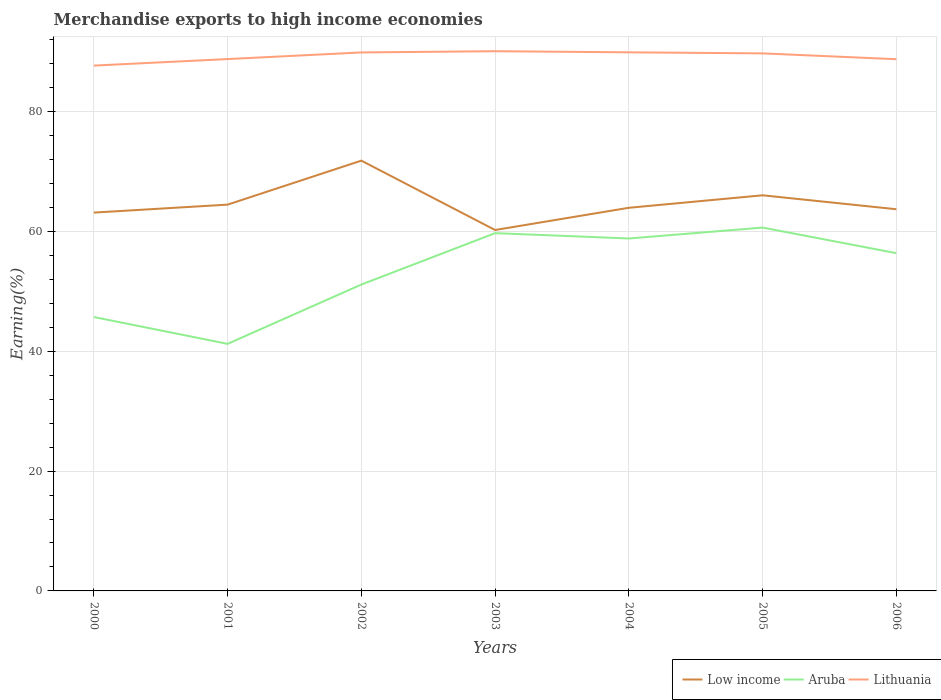How many different coloured lines are there?
Provide a succinct answer. 3. Does the line corresponding to Lithuania intersect with the line corresponding to Aruba?
Provide a succinct answer. No. Across all years, what is the maximum percentage of amount earned from merchandise exports in Low income?
Offer a terse response. 60.23. In which year was the percentage of amount earned from merchandise exports in Low income maximum?
Offer a terse response. 2003. What is the total percentage of amount earned from merchandise exports in Low income in the graph?
Offer a terse response. 5.78. What is the difference between the highest and the second highest percentage of amount earned from merchandise exports in Lithuania?
Give a very brief answer. 2.4. What is the difference between the highest and the lowest percentage of amount earned from merchandise exports in Lithuania?
Make the answer very short. 4. Are the values on the major ticks of Y-axis written in scientific E-notation?
Keep it short and to the point. No. Does the graph contain grids?
Ensure brevity in your answer.  Yes. Where does the legend appear in the graph?
Make the answer very short. Bottom right. What is the title of the graph?
Your answer should be compact. Merchandise exports to high income economies. Does "Iran" appear as one of the legend labels in the graph?
Offer a terse response. No. What is the label or title of the Y-axis?
Give a very brief answer. Earning(%). What is the Earning(%) of Low income in 2000?
Provide a succinct answer. 63.13. What is the Earning(%) in Aruba in 2000?
Ensure brevity in your answer.  45.71. What is the Earning(%) of Lithuania in 2000?
Your response must be concise. 87.66. What is the Earning(%) in Low income in 2001?
Provide a succinct answer. 64.46. What is the Earning(%) of Aruba in 2001?
Keep it short and to the point. 41.23. What is the Earning(%) in Lithuania in 2001?
Your response must be concise. 88.75. What is the Earning(%) of Low income in 2002?
Your answer should be compact. 71.8. What is the Earning(%) of Aruba in 2002?
Provide a succinct answer. 51.13. What is the Earning(%) of Lithuania in 2002?
Give a very brief answer. 89.86. What is the Earning(%) in Low income in 2003?
Offer a very short reply. 60.23. What is the Earning(%) of Aruba in 2003?
Offer a terse response. 59.7. What is the Earning(%) of Lithuania in 2003?
Your answer should be very brief. 90.06. What is the Earning(%) in Low income in 2004?
Ensure brevity in your answer.  63.93. What is the Earning(%) in Aruba in 2004?
Make the answer very short. 58.81. What is the Earning(%) of Lithuania in 2004?
Keep it short and to the point. 89.87. What is the Earning(%) in Low income in 2005?
Your answer should be very brief. 66.02. What is the Earning(%) in Aruba in 2005?
Ensure brevity in your answer.  60.63. What is the Earning(%) in Lithuania in 2005?
Your response must be concise. 89.7. What is the Earning(%) in Low income in 2006?
Keep it short and to the point. 63.69. What is the Earning(%) in Aruba in 2006?
Your answer should be very brief. 56.36. What is the Earning(%) of Lithuania in 2006?
Ensure brevity in your answer.  88.73. Across all years, what is the maximum Earning(%) in Low income?
Make the answer very short. 71.8. Across all years, what is the maximum Earning(%) in Aruba?
Provide a short and direct response. 60.63. Across all years, what is the maximum Earning(%) in Lithuania?
Offer a terse response. 90.06. Across all years, what is the minimum Earning(%) of Low income?
Your answer should be compact. 60.23. Across all years, what is the minimum Earning(%) of Aruba?
Provide a succinct answer. 41.23. Across all years, what is the minimum Earning(%) of Lithuania?
Your answer should be compact. 87.66. What is the total Earning(%) of Low income in the graph?
Offer a very short reply. 453.26. What is the total Earning(%) in Aruba in the graph?
Offer a very short reply. 373.56. What is the total Earning(%) of Lithuania in the graph?
Ensure brevity in your answer.  624.63. What is the difference between the Earning(%) of Low income in 2000 and that in 2001?
Your answer should be compact. -1.33. What is the difference between the Earning(%) of Aruba in 2000 and that in 2001?
Offer a terse response. 4.48. What is the difference between the Earning(%) in Lithuania in 2000 and that in 2001?
Your response must be concise. -1.09. What is the difference between the Earning(%) of Low income in 2000 and that in 2002?
Provide a succinct answer. -8.67. What is the difference between the Earning(%) of Aruba in 2000 and that in 2002?
Provide a succinct answer. -5.42. What is the difference between the Earning(%) in Lithuania in 2000 and that in 2002?
Provide a succinct answer. -2.2. What is the difference between the Earning(%) of Low income in 2000 and that in 2003?
Ensure brevity in your answer.  2.9. What is the difference between the Earning(%) of Aruba in 2000 and that in 2003?
Your response must be concise. -14. What is the difference between the Earning(%) of Lithuania in 2000 and that in 2003?
Provide a succinct answer. -2.4. What is the difference between the Earning(%) of Low income in 2000 and that in 2004?
Make the answer very short. -0.8. What is the difference between the Earning(%) in Aruba in 2000 and that in 2004?
Provide a short and direct response. -13.11. What is the difference between the Earning(%) of Lithuania in 2000 and that in 2004?
Provide a short and direct response. -2.21. What is the difference between the Earning(%) in Low income in 2000 and that in 2005?
Ensure brevity in your answer.  -2.89. What is the difference between the Earning(%) in Aruba in 2000 and that in 2005?
Offer a very short reply. -14.93. What is the difference between the Earning(%) of Lithuania in 2000 and that in 2005?
Your response must be concise. -2.04. What is the difference between the Earning(%) of Low income in 2000 and that in 2006?
Offer a very short reply. -0.56. What is the difference between the Earning(%) in Aruba in 2000 and that in 2006?
Provide a short and direct response. -10.66. What is the difference between the Earning(%) in Lithuania in 2000 and that in 2006?
Make the answer very short. -1.07. What is the difference between the Earning(%) in Low income in 2001 and that in 2002?
Offer a terse response. -7.34. What is the difference between the Earning(%) in Aruba in 2001 and that in 2002?
Keep it short and to the point. -9.9. What is the difference between the Earning(%) in Lithuania in 2001 and that in 2002?
Offer a very short reply. -1.11. What is the difference between the Earning(%) of Low income in 2001 and that in 2003?
Offer a terse response. 4.23. What is the difference between the Earning(%) of Aruba in 2001 and that in 2003?
Your response must be concise. -18.48. What is the difference between the Earning(%) of Lithuania in 2001 and that in 2003?
Your response must be concise. -1.31. What is the difference between the Earning(%) of Low income in 2001 and that in 2004?
Your answer should be very brief. 0.53. What is the difference between the Earning(%) in Aruba in 2001 and that in 2004?
Keep it short and to the point. -17.59. What is the difference between the Earning(%) in Lithuania in 2001 and that in 2004?
Keep it short and to the point. -1.13. What is the difference between the Earning(%) in Low income in 2001 and that in 2005?
Give a very brief answer. -1.56. What is the difference between the Earning(%) in Aruba in 2001 and that in 2005?
Provide a short and direct response. -19.41. What is the difference between the Earning(%) of Lithuania in 2001 and that in 2005?
Offer a very short reply. -0.95. What is the difference between the Earning(%) in Low income in 2001 and that in 2006?
Keep it short and to the point. 0.77. What is the difference between the Earning(%) of Aruba in 2001 and that in 2006?
Your response must be concise. -15.14. What is the difference between the Earning(%) of Lithuania in 2001 and that in 2006?
Offer a terse response. 0.02. What is the difference between the Earning(%) of Low income in 2002 and that in 2003?
Make the answer very short. 11.57. What is the difference between the Earning(%) of Aruba in 2002 and that in 2003?
Keep it short and to the point. -8.58. What is the difference between the Earning(%) in Lithuania in 2002 and that in 2003?
Offer a terse response. -0.2. What is the difference between the Earning(%) of Low income in 2002 and that in 2004?
Make the answer very short. 7.87. What is the difference between the Earning(%) in Aruba in 2002 and that in 2004?
Offer a very short reply. -7.69. What is the difference between the Earning(%) of Lithuania in 2002 and that in 2004?
Give a very brief answer. -0.02. What is the difference between the Earning(%) of Low income in 2002 and that in 2005?
Provide a short and direct response. 5.78. What is the difference between the Earning(%) of Aruba in 2002 and that in 2005?
Give a very brief answer. -9.51. What is the difference between the Earning(%) in Lithuania in 2002 and that in 2005?
Your response must be concise. 0.16. What is the difference between the Earning(%) of Low income in 2002 and that in 2006?
Provide a succinct answer. 8.11. What is the difference between the Earning(%) in Aruba in 2002 and that in 2006?
Provide a short and direct response. -5.24. What is the difference between the Earning(%) of Lithuania in 2002 and that in 2006?
Provide a short and direct response. 1.13. What is the difference between the Earning(%) of Low income in 2003 and that in 2004?
Offer a very short reply. -3.71. What is the difference between the Earning(%) in Aruba in 2003 and that in 2004?
Provide a short and direct response. 0.89. What is the difference between the Earning(%) of Lithuania in 2003 and that in 2004?
Your response must be concise. 0.19. What is the difference between the Earning(%) in Low income in 2003 and that in 2005?
Keep it short and to the point. -5.79. What is the difference between the Earning(%) in Aruba in 2003 and that in 2005?
Offer a very short reply. -0.93. What is the difference between the Earning(%) of Lithuania in 2003 and that in 2005?
Your answer should be very brief. 0.36. What is the difference between the Earning(%) in Low income in 2003 and that in 2006?
Provide a succinct answer. -3.47. What is the difference between the Earning(%) in Aruba in 2003 and that in 2006?
Your answer should be very brief. 3.34. What is the difference between the Earning(%) in Lithuania in 2003 and that in 2006?
Offer a terse response. 1.33. What is the difference between the Earning(%) of Low income in 2004 and that in 2005?
Provide a succinct answer. -2.08. What is the difference between the Earning(%) of Aruba in 2004 and that in 2005?
Ensure brevity in your answer.  -1.82. What is the difference between the Earning(%) of Lithuania in 2004 and that in 2005?
Your answer should be very brief. 0.18. What is the difference between the Earning(%) in Low income in 2004 and that in 2006?
Provide a succinct answer. 0.24. What is the difference between the Earning(%) of Aruba in 2004 and that in 2006?
Your response must be concise. 2.45. What is the difference between the Earning(%) of Lithuania in 2004 and that in 2006?
Your response must be concise. 1.15. What is the difference between the Earning(%) in Low income in 2005 and that in 2006?
Ensure brevity in your answer.  2.33. What is the difference between the Earning(%) of Aruba in 2005 and that in 2006?
Ensure brevity in your answer.  4.27. What is the difference between the Earning(%) of Lithuania in 2005 and that in 2006?
Your answer should be very brief. 0.97. What is the difference between the Earning(%) of Low income in 2000 and the Earning(%) of Aruba in 2001?
Your response must be concise. 21.91. What is the difference between the Earning(%) of Low income in 2000 and the Earning(%) of Lithuania in 2001?
Provide a short and direct response. -25.62. What is the difference between the Earning(%) of Aruba in 2000 and the Earning(%) of Lithuania in 2001?
Your answer should be compact. -43.04. What is the difference between the Earning(%) in Low income in 2000 and the Earning(%) in Aruba in 2002?
Your response must be concise. 12.01. What is the difference between the Earning(%) of Low income in 2000 and the Earning(%) of Lithuania in 2002?
Ensure brevity in your answer.  -26.73. What is the difference between the Earning(%) in Aruba in 2000 and the Earning(%) in Lithuania in 2002?
Make the answer very short. -44.15. What is the difference between the Earning(%) of Low income in 2000 and the Earning(%) of Aruba in 2003?
Provide a short and direct response. 3.43. What is the difference between the Earning(%) in Low income in 2000 and the Earning(%) in Lithuania in 2003?
Make the answer very short. -26.93. What is the difference between the Earning(%) of Aruba in 2000 and the Earning(%) of Lithuania in 2003?
Provide a succinct answer. -44.36. What is the difference between the Earning(%) of Low income in 2000 and the Earning(%) of Aruba in 2004?
Your answer should be compact. 4.32. What is the difference between the Earning(%) of Low income in 2000 and the Earning(%) of Lithuania in 2004?
Your answer should be very brief. -26.74. What is the difference between the Earning(%) of Aruba in 2000 and the Earning(%) of Lithuania in 2004?
Ensure brevity in your answer.  -44.17. What is the difference between the Earning(%) of Low income in 2000 and the Earning(%) of Aruba in 2005?
Provide a short and direct response. 2.5. What is the difference between the Earning(%) of Low income in 2000 and the Earning(%) of Lithuania in 2005?
Offer a terse response. -26.57. What is the difference between the Earning(%) in Aruba in 2000 and the Earning(%) in Lithuania in 2005?
Make the answer very short. -43.99. What is the difference between the Earning(%) of Low income in 2000 and the Earning(%) of Aruba in 2006?
Your answer should be compact. 6.77. What is the difference between the Earning(%) in Low income in 2000 and the Earning(%) in Lithuania in 2006?
Give a very brief answer. -25.6. What is the difference between the Earning(%) in Aruba in 2000 and the Earning(%) in Lithuania in 2006?
Your answer should be compact. -43.02. What is the difference between the Earning(%) in Low income in 2001 and the Earning(%) in Aruba in 2002?
Offer a very short reply. 13.34. What is the difference between the Earning(%) in Low income in 2001 and the Earning(%) in Lithuania in 2002?
Provide a succinct answer. -25.4. What is the difference between the Earning(%) of Aruba in 2001 and the Earning(%) of Lithuania in 2002?
Provide a succinct answer. -48.63. What is the difference between the Earning(%) of Low income in 2001 and the Earning(%) of Aruba in 2003?
Your answer should be very brief. 4.76. What is the difference between the Earning(%) in Low income in 2001 and the Earning(%) in Lithuania in 2003?
Make the answer very short. -25.6. What is the difference between the Earning(%) in Aruba in 2001 and the Earning(%) in Lithuania in 2003?
Ensure brevity in your answer.  -48.84. What is the difference between the Earning(%) of Low income in 2001 and the Earning(%) of Aruba in 2004?
Provide a succinct answer. 5.65. What is the difference between the Earning(%) in Low income in 2001 and the Earning(%) in Lithuania in 2004?
Provide a short and direct response. -25.41. What is the difference between the Earning(%) in Aruba in 2001 and the Earning(%) in Lithuania in 2004?
Your answer should be compact. -48.65. What is the difference between the Earning(%) in Low income in 2001 and the Earning(%) in Aruba in 2005?
Your answer should be very brief. 3.83. What is the difference between the Earning(%) in Low income in 2001 and the Earning(%) in Lithuania in 2005?
Keep it short and to the point. -25.24. What is the difference between the Earning(%) in Aruba in 2001 and the Earning(%) in Lithuania in 2005?
Ensure brevity in your answer.  -48.47. What is the difference between the Earning(%) of Low income in 2001 and the Earning(%) of Aruba in 2006?
Your answer should be compact. 8.1. What is the difference between the Earning(%) of Low income in 2001 and the Earning(%) of Lithuania in 2006?
Provide a short and direct response. -24.27. What is the difference between the Earning(%) in Aruba in 2001 and the Earning(%) in Lithuania in 2006?
Ensure brevity in your answer.  -47.5. What is the difference between the Earning(%) of Low income in 2002 and the Earning(%) of Aruba in 2003?
Keep it short and to the point. 12.1. What is the difference between the Earning(%) in Low income in 2002 and the Earning(%) in Lithuania in 2003?
Your response must be concise. -18.26. What is the difference between the Earning(%) in Aruba in 2002 and the Earning(%) in Lithuania in 2003?
Keep it short and to the point. -38.94. What is the difference between the Earning(%) of Low income in 2002 and the Earning(%) of Aruba in 2004?
Your answer should be compact. 12.99. What is the difference between the Earning(%) of Low income in 2002 and the Earning(%) of Lithuania in 2004?
Give a very brief answer. -18.07. What is the difference between the Earning(%) of Aruba in 2002 and the Earning(%) of Lithuania in 2004?
Offer a terse response. -38.75. What is the difference between the Earning(%) of Low income in 2002 and the Earning(%) of Aruba in 2005?
Provide a short and direct response. 11.17. What is the difference between the Earning(%) of Low income in 2002 and the Earning(%) of Lithuania in 2005?
Give a very brief answer. -17.9. What is the difference between the Earning(%) in Aruba in 2002 and the Earning(%) in Lithuania in 2005?
Ensure brevity in your answer.  -38.57. What is the difference between the Earning(%) of Low income in 2002 and the Earning(%) of Aruba in 2006?
Offer a terse response. 15.44. What is the difference between the Earning(%) in Low income in 2002 and the Earning(%) in Lithuania in 2006?
Offer a terse response. -16.93. What is the difference between the Earning(%) of Aruba in 2002 and the Earning(%) of Lithuania in 2006?
Your answer should be very brief. -37.6. What is the difference between the Earning(%) of Low income in 2003 and the Earning(%) of Aruba in 2004?
Offer a terse response. 1.42. What is the difference between the Earning(%) in Low income in 2003 and the Earning(%) in Lithuania in 2004?
Make the answer very short. -29.65. What is the difference between the Earning(%) in Aruba in 2003 and the Earning(%) in Lithuania in 2004?
Your response must be concise. -30.17. What is the difference between the Earning(%) of Low income in 2003 and the Earning(%) of Aruba in 2005?
Ensure brevity in your answer.  -0.4. What is the difference between the Earning(%) of Low income in 2003 and the Earning(%) of Lithuania in 2005?
Give a very brief answer. -29.47. What is the difference between the Earning(%) in Aruba in 2003 and the Earning(%) in Lithuania in 2005?
Your answer should be compact. -30. What is the difference between the Earning(%) of Low income in 2003 and the Earning(%) of Aruba in 2006?
Make the answer very short. 3.87. What is the difference between the Earning(%) in Low income in 2003 and the Earning(%) in Lithuania in 2006?
Provide a succinct answer. -28.5. What is the difference between the Earning(%) of Aruba in 2003 and the Earning(%) of Lithuania in 2006?
Your answer should be compact. -29.03. What is the difference between the Earning(%) in Low income in 2004 and the Earning(%) in Aruba in 2005?
Ensure brevity in your answer.  3.3. What is the difference between the Earning(%) in Low income in 2004 and the Earning(%) in Lithuania in 2005?
Your answer should be compact. -25.77. What is the difference between the Earning(%) in Aruba in 2004 and the Earning(%) in Lithuania in 2005?
Provide a short and direct response. -30.89. What is the difference between the Earning(%) in Low income in 2004 and the Earning(%) in Aruba in 2006?
Give a very brief answer. 7.57. What is the difference between the Earning(%) in Low income in 2004 and the Earning(%) in Lithuania in 2006?
Your response must be concise. -24.79. What is the difference between the Earning(%) in Aruba in 2004 and the Earning(%) in Lithuania in 2006?
Provide a succinct answer. -29.92. What is the difference between the Earning(%) in Low income in 2005 and the Earning(%) in Aruba in 2006?
Give a very brief answer. 9.66. What is the difference between the Earning(%) of Low income in 2005 and the Earning(%) of Lithuania in 2006?
Your answer should be compact. -22.71. What is the difference between the Earning(%) in Aruba in 2005 and the Earning(%) in Lithuania in 2006?
Provide a succinct answer. -28.1. What is the average Earning(%) in Low income per year?
Your response must be concise. 64.75. What is the average Earning(%) in Aruba per year?
Your answer should be compact. 53.37. What is the average Earning(%) of Lithuania per year?
Ensure brevity in your answer.  89.23. In the year 2000, what is the difference between the Earning(%) in Low income and Earning(%) in Aruba?
Make the answer very short. 17.43. In the year 2000, what is the difference between the Earning(%) of Low income and Earning(%) of Lithuania?
Your answer should be very brief. -24.53. In the year 2000, what is the difference between the Earning(%) in Aruba and Earning(%) in Lithuania?
Make the answer very short. -41.96. In the year 2001, what is the difference between the Earning(%) of Low income and Earning(%) of Aruba?
Ensure brevity in your answer.  23.24. In the year 2001, what is the difference between the Earning(%) in Low income and Earning(%) in Lithuania?
Offer a very short reply. -24.29. In the year 2001, what is the difference between the Earning(%) of Aruba and Earning(%) of Lithuania?
Provide a short and direct response. -47.52. In the year 2002, what is the difference between the Earning(%) of Low income and Earning(%) of Aruba?
Offer a very short reply. 20.68. In the year 2002, what is the difference between the Earning(%) of Low income and Earning(%) of Lithuania?
Offer a very short reply. -18.06. In the year 2002, what is the difference between the Earning(%) in Aruba and Earning(%) in Lithuania?
Provide a short and direct response. -38.73. In the year 2003, what is the difference between the Earning(%) of Low income and Earning(%) of Aruba?
Offer a very short reply. 0.52. In the year 2003, what is the difference between the Earning(%) in Low income and Earning(%) in Lithuania?
Provide a short and direct response. -29.84. In the year 2003, what is the difference between the Earning(%) in Aruba and Earning(%) in Lithuania?
Your answer should be compact. -30.36. In the year 2004, what is the difference between the Earning(%) of Low income and Earning(%) of Aruba?
Make the answer very short. 5.12. In the year 2004, what is the difference between the Earning(%) in Low income and Earning(%) in Lithuania?
Your answer should be very brief. -25.94. In the year 2004, what is the difference between the Earning(%) of Aruba and Earning(%) of Lithuania?
Provide a succinct answer. -31.06. In the year 2005, what is the difference between the Earning(%) of Low income and Earning(%) of Aruba?
Your answer should be very brief. 5.39. In the year 2005, what is the difference between the Earning(%) in Low income and Earning(%) in Lithuania?
Ensure brevity in your answer.  -23.68. In the year 2005, what is the difference between the Earning(%) in Aruba and Earning(%) in Lithuania?
Provide a short and direct response. -29.07. In the year 2006, what is the difference between the Earning(%) in Low income and Earning(%) in Aruba?
Provide a succinct answer. 7.33. In the year 2006, what is the difference between the Earning(%) in Low income and Earning(%) in Lithuania?
Ensure brevity in your answer.  -25.04. In the year 2006, what is the difference between the Earning(%) of Aruba and Earning(%) of Lithuania?
Give a very brief answer. -32.37. What is the ratio of the Earning(%) of Low income in 2000 to that in 2001?
Give a very brief answer. 0.98. What is the ratio of the Earning(%) in Aruba in 2000 to that in 2001?
Keep it short and to the point. 1.11. What is the ratio of the Earning(%) of Lithuania in 2000 to that in 2001?
Keep it short and to the point. 0.99. What is the ratio of the Earning(%) of Low income in 2000 to that in 2002?
Your answer should be compact. 0.88. What is the ratio of the Earning(%) of Aruba in 2000 to that in 2002?
Your answer should be compact. 0.89. What is the ratio of the Earning(%) in Lithuania in 2000 to that in 2002?
Your answer should be very brief. 0.98. What is the ratio of the Earning(%) in Low income in 2000 to that in 2003?
Make the answer very short. 1.05. What is the ratio of the Earning(%) in Aruba in 2000 to that in 2003?
Offer a terse response. 0.77. What is the ratio of the Earning(%) in Lithuania in 2000 to that in 2003?
Keep it short and to the point. 0.97. What is the ratio of the Earning(%) in Low income in 2000 to that in 2004?
Give a very brief answer. 0.99. What is the ratio of the Earning(%) in Aruba in 2000 to that in 2004?
Ensure brevity in your answer.  0.78. What is the ratio of the Earning(%) of Lithuania in 2000 to that in 2004?
Keep it short and to the point. 0.98. What is the ratio of the Earning(%) in Low income in 2000 to that in 2005?
Offer a very short reply. 0.96. What is the ratio of the Earning(%) in Aruba in 2000 to that in 2005?
Give a very brief answer. 0.75. What is the ratio of the Earning(%) of Lithuania in 2000 to that in 2005?
Your response must be concise. 0.98. What is the ratio of the Earning(%) in Low income in 2000 to that in 2006?
Provide a succinct answer. 0.99. What is the ratio of the Earning(%) in Aruba in 2000 to that in 2006?
Provide a succinct answer. 0.81. What is the ratio of the Earning(%) in Low income in 2001 to that in 2002?
Offer a terse response. 0.9. What is the ratio of the Earning(%) of Aruba in 2001 to that in 2002?
Your response must be concise. 0.81. What is the ratio of the Earning(%) of Lithuania in 2001 to that in 2002?
Ensure brevity in your answer.  0.99. What is the ratio of the Earning(%) in Low income in 2001 to that in 2003?
Ensure brevity in your answer.  1.07. What is the ratio of the Earning(%) of Aruba in 2001 to that in 2003?
Offer a very short reply. 0.69. What is the ratio of the Earning(%) in Lithuania in 2001 to that in 2003?
Your answer should be compact. 0.99. What is the ratio of the Earning(%) in Low income in 2001 to that in 2004?
Offer a terse response. 1.01. What is the ratio of the Earning(%) in Aruba in 2001 to that in 2004?
Keep it short and to the point. 0.7. What is the ratio of the Earning(%) in Lithuania in 2001 to that in 2004?
Keep it short and to the point. 0.99. What is the ratio of the Earning(%) of Low income in 2001 to that in 2005?
Provide a succinct answer. 0.98. What is the ratio of the Earning(%) of Aruba in 2001 to that in 2005?
Keep it short and to the point. 0.68. What is the ratio of the Earning(%) of Low income in 2001 to that in 2006?
Your answer should be very brief. 1.01. What is the ratio of the Earning(%) in Aruba in 2001 to that in 2006?
Your answer should be compact. 0.73. What is the ratio of the Earning(%) of Low income in 2002 to that in 2003?
Your answer should be very brief. 1.19. What is the ratio of the Earning(%) of Aruba in 2002 to that in 2003?
Offer a terse response. 0.86. What is the ratio of the Earning(%) of Low income in 2002 to that in 2004?
Your answer should be compact. 1.12. What is the ratio of the Earning(%) in Aruba in 2002 to that in 2004?
Give a very brief answer. 0.87. What is the ratio of the Earning(%) of Low income in 2002 to that in 2005?
Make the answer very short. 1.09. What is the ratio of the Earning(%) in Aruba in 2002 to that in 2005?
Keep it short and to the point. 0.84. What is the ratio of the Earning(%) in Lithuania in 2002 to that in 2005?
Keep it short and to the point. 1. What is the ratio of the Earning(%) of Low income in 2002 to that in 2006?
Offer a very short reply. 1.13. What is the ratio of the Earning(%) in Aruba in 2002 to that in 2006?
Your answer should be very brief. 0.91. What is the ratio of the Earning(%) of Lithuania in 2002 to that in 2006?
Your response must be concise. 1.01. What is the ratio of the Earning(%) in Low income in 2003 to that in 2004?
Your answer should be very brief. 0.94. What is the ratio of the Earning(%) in Aruba in 2003 to that in 2004?
Your response must be concise. 1.02. What is the ratio of the Earning(%) in Lithuania in 2003 to that in 2004?
Keep it short and to the point. 1. What is the ratio of the Earning(%) in Low income in 2003 to that in 2005?
Offer a terse response. 0.91. What is the ratio of the Earning(%) of Aruba in 2003 to that in 2005?
Your response must be concise. 0.98. What is the ratio of the Earning(%) of Lithuania in 2003 to that in 2005?
Your answer should be very brief. 1. What is the ratio of the Earning(%) of Low income in 2003 to that in 2006?
Make the answer very short. 0.95. What is the ratio of the Earning(%) in Aruba in 2003 to that in 2006?
Your answer should be very brief. 1.06. What is the ratio of the Earning(%) of Low income in 2004 to that in 2005?
Offer a very short reply. 0.97. What is the ratio of the Earning(%) of Lithuania in 2004 to that in 2005?
Provide a succinct answer. 1. What is the ratio of the Earning(%) of Low income in 2004 to that in 2006?
Offer a very short reply. 1. What is the ratio of the Earning(%) in Aruba in 2004 to that in 2006?
Offer a terse response. 1.04. What is the ratio of the Earning(%) in Lithuania in 2004 to that in 2006?
Make the answer very short. 1.01. What is the ratio of the Earning(%) in Low income in 2005 to that in 2006?
Your response must be concise. 1.04. What is the ratio of the Earning(%) in Aruba in 2005 to that in 2006?
Ensure brevity in your answer.  1.08. What is the ratio of the Earning(%) of Lithuania in 2005 to that in 2006?
Your answer should be compact. 1.01. What is the difference between the highest and the second highest Earning(%) of Low income?
Provide a succinct answer. 5.78. What is the difference between the highest and the second highest Earning(%) in Aruba?
Provide a succinct answer. 0.93. What is the difference between the highest and the second highest Earning(%) of Lithuania?
Your answer should be very brief. 0.19. What is the difference between the highest and the lowest Earning(%) in Low income?
Your answer should be very brief. 11.57. What is the difference between the highest and the lowest Earning(%) of Aruba?
Provide a succinct answer. 19.41. What is the difference between the highest and the lowest Earning(%) of Lithuania?
Offer a terse response. 2.4. 